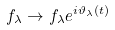Convert formula to latex. <formula><loc_0><loc_0><loc_500><loc_500>f _ { \lambda } \to f _ { \lambda } e ^ { i \vartheta _ { \lambda } ( t ) }</formula> 